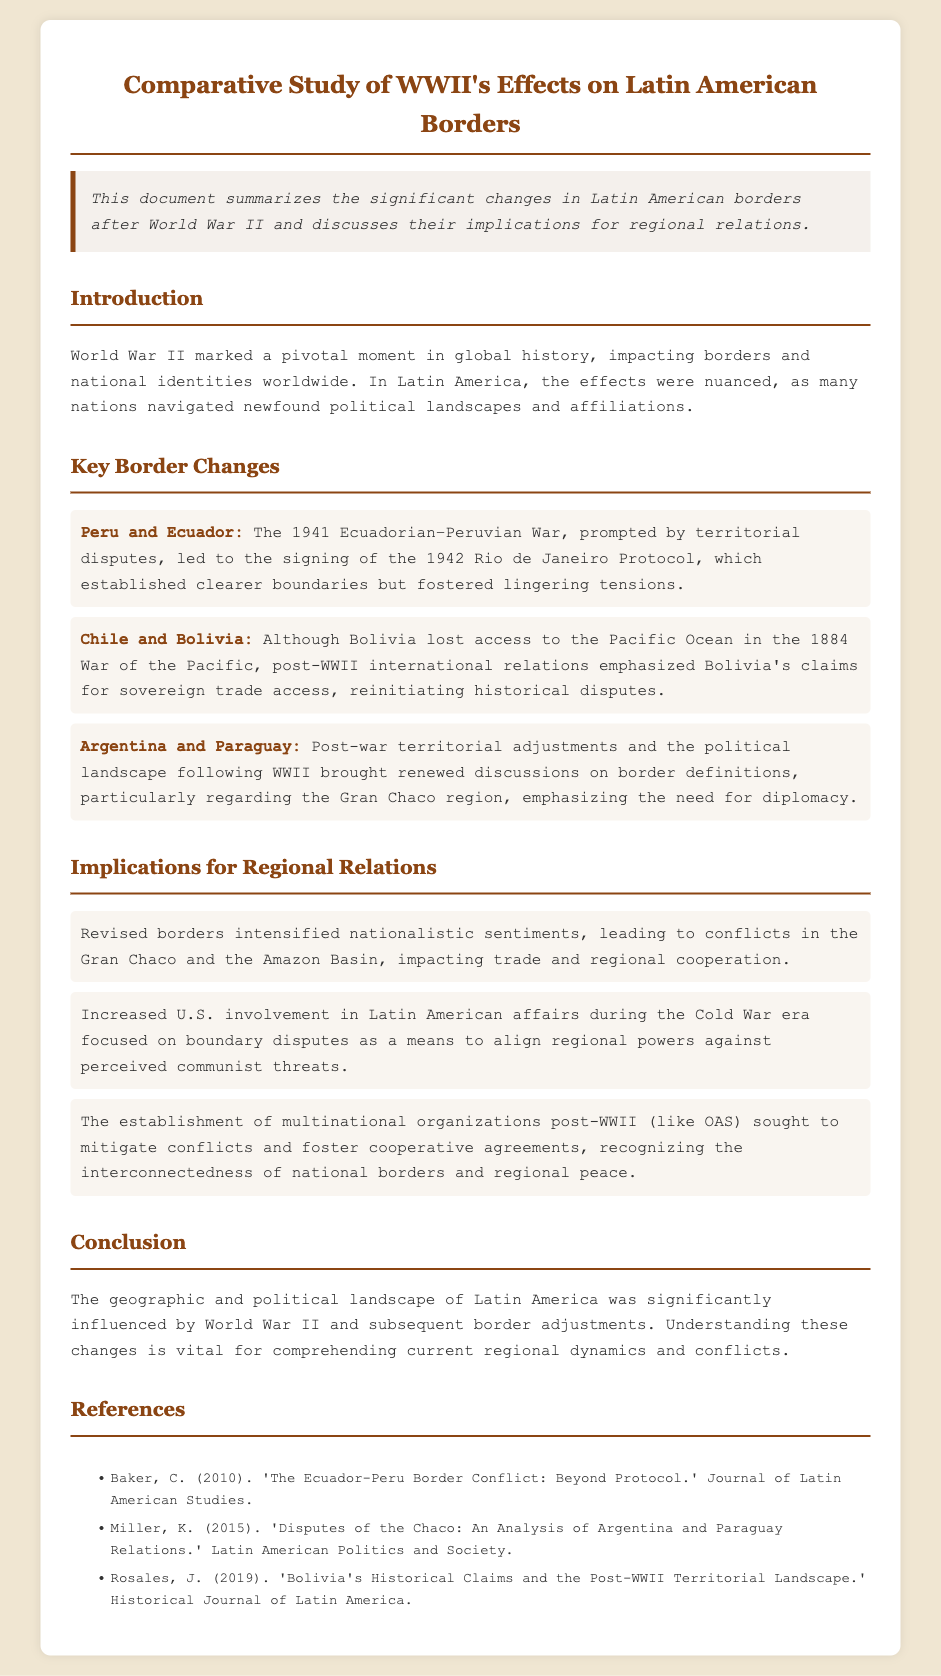What was the primary focus of the document? The document focuses on summarizing the significant changes in Latin American borders after World War II and discussing their implications for regional relations.
Answer: Changes in Latin American borders Which two countries were involved in the 1941 conflict? The document states that the 1941 Ecuadorian–Peruvian War involved Peru and Ecuador.
Answer: Peru and Ecuador What was a significant outcome of the Chile and Bolivia relations post-WWII? The document mentions that post-WWII relations emphasized Bolivia's claims for sovereign trade access, reinitiating historical disputes.
Answer: Historical disputes What organization was established to mitigate conflicts post-WWII? The document refers to the Organization of American States (OAS) as a multinational organization that sought to mitigate conflicts.
Answer: OAS Which region's border discussions were renewed between Argentina and Paraguay after WWII? The document specifically notes renewed discussions on border definitions regarding the Gran Chaco region.
Answer: Gran Chaco How did U.S. involvement in Latin America change during the Cold War era? The document explains that U.S. involvement increased during the Cold War, focusing on boundary disputes as a means to align regional powers against perceived communist threats.
Answer: Increased involvement What type of sentiment was intensified due to the revised borders? According to the document, revised borders intensified nationalistic sentiments in the region.
Answer: Nationalistic sentiments Which year did the Rio de Janeiro Protocol get signed? The document states the Rio de Janeiro Protocol was signed in 1942.
Answer: 1942 